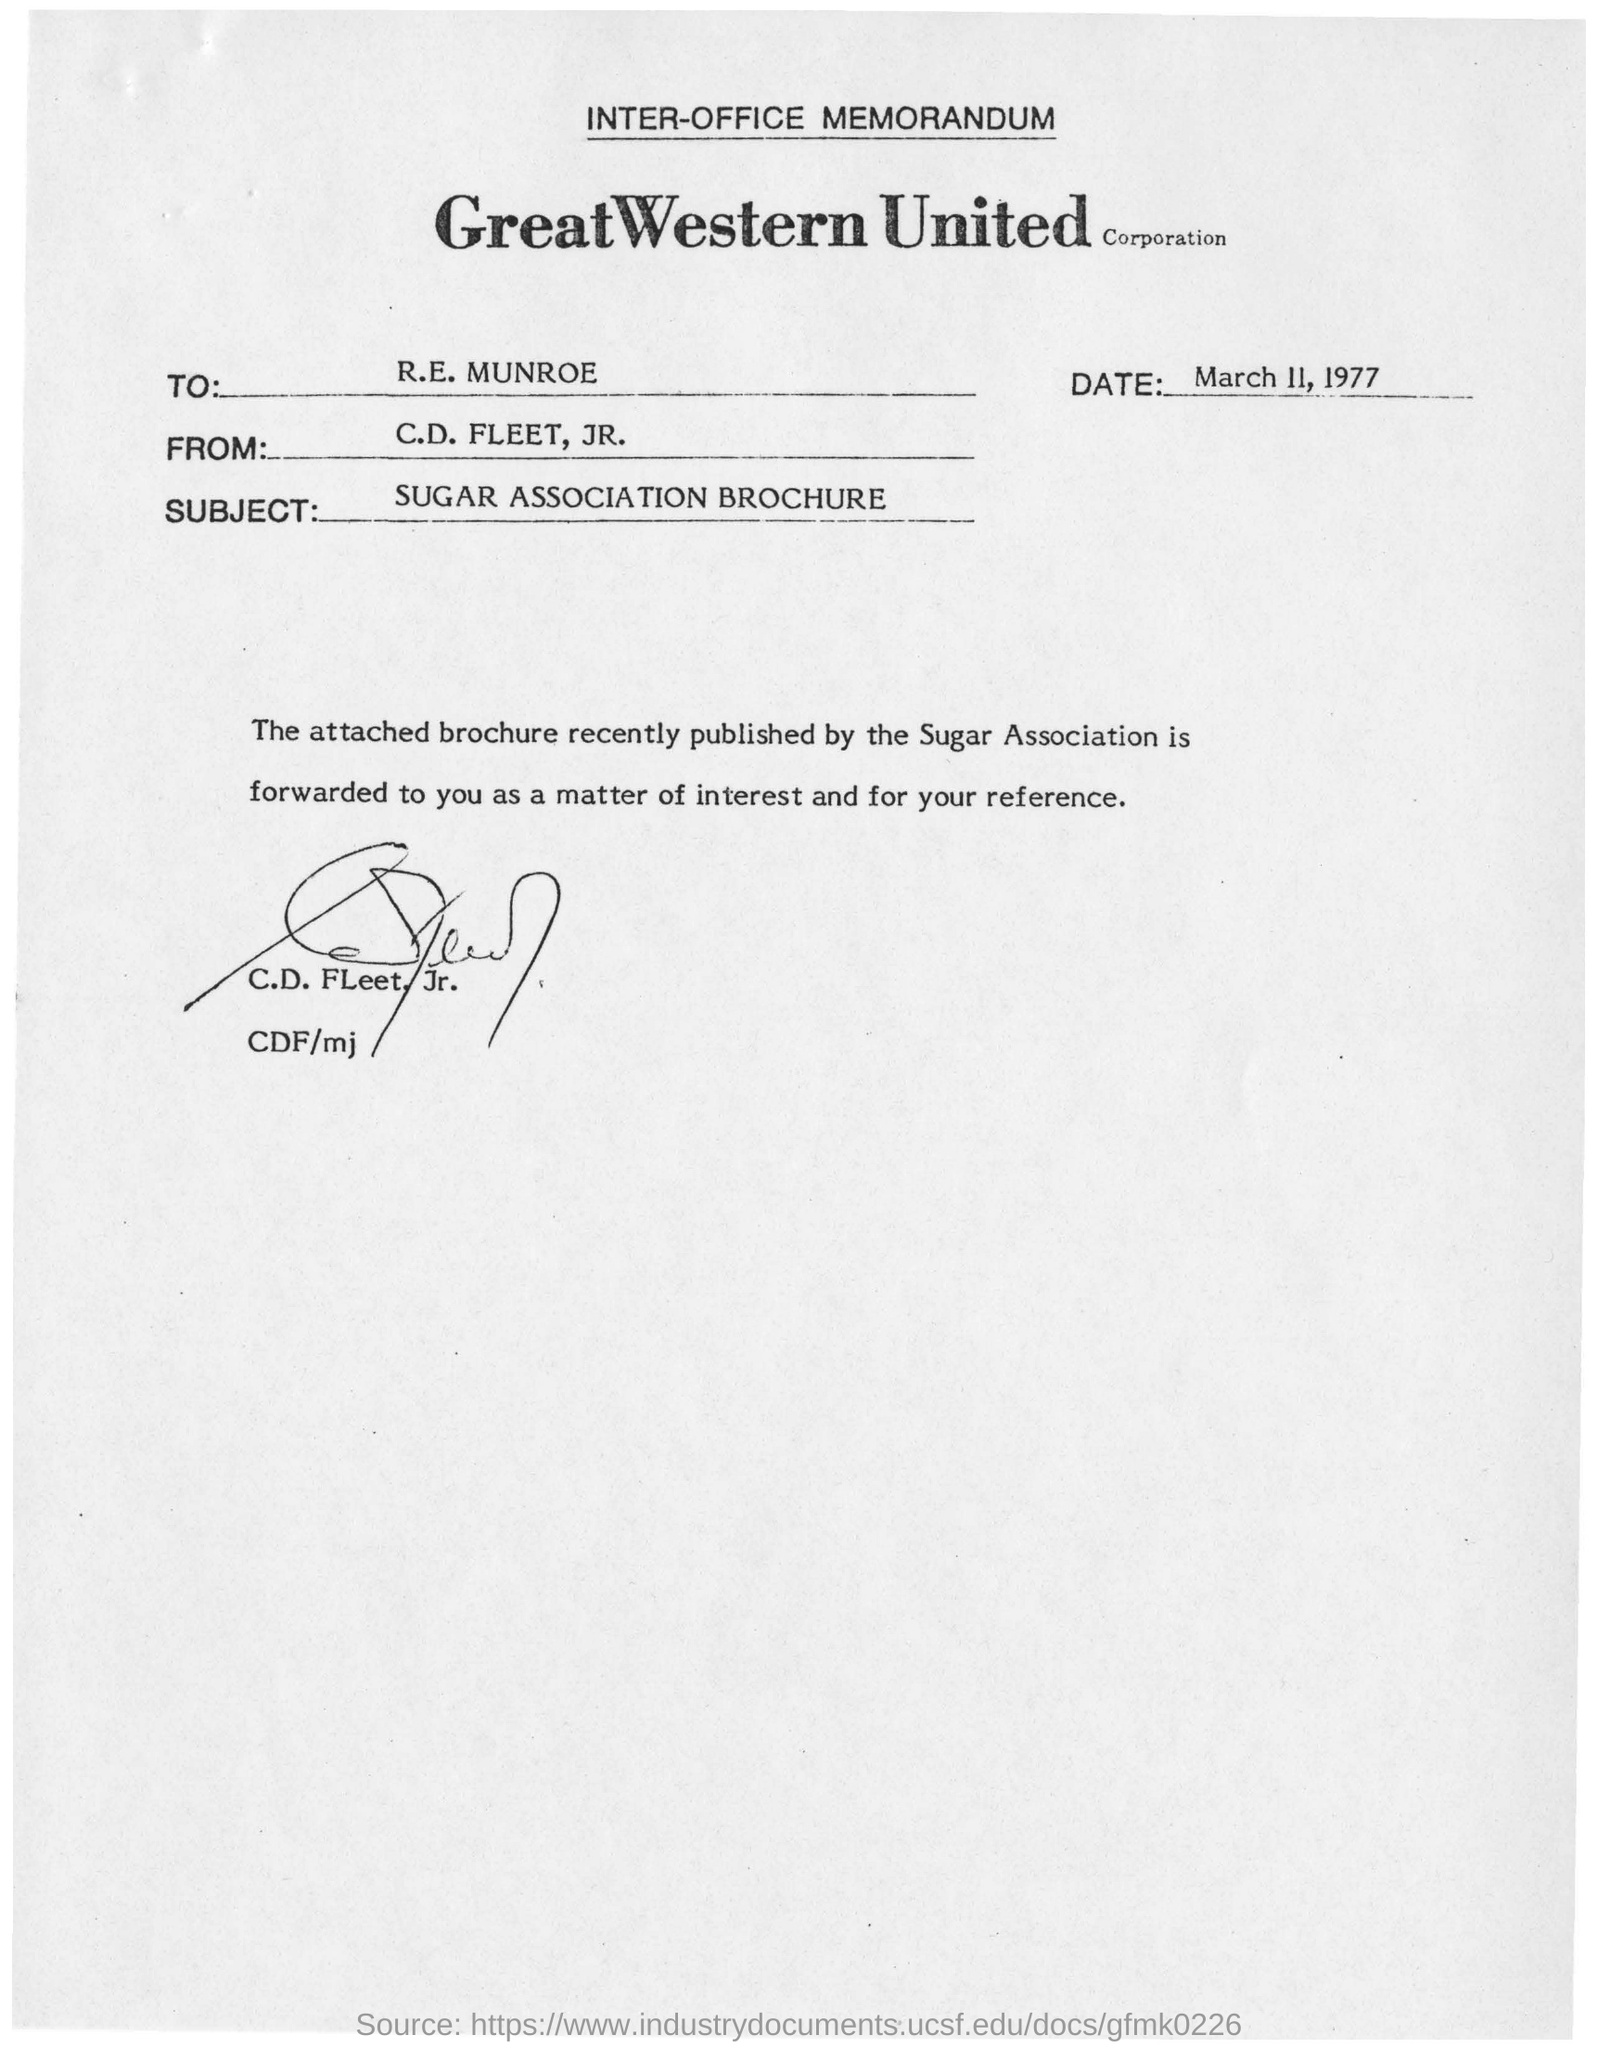Highlight a few significant elements in this photo. The memorandum is addressed to R.E. Munroe. The Sugar Association recently published a brochure. C.D. Fleet, Jr. has signed this memorandum. The subject of the letter is a brochure produced by the Sugar Association. 